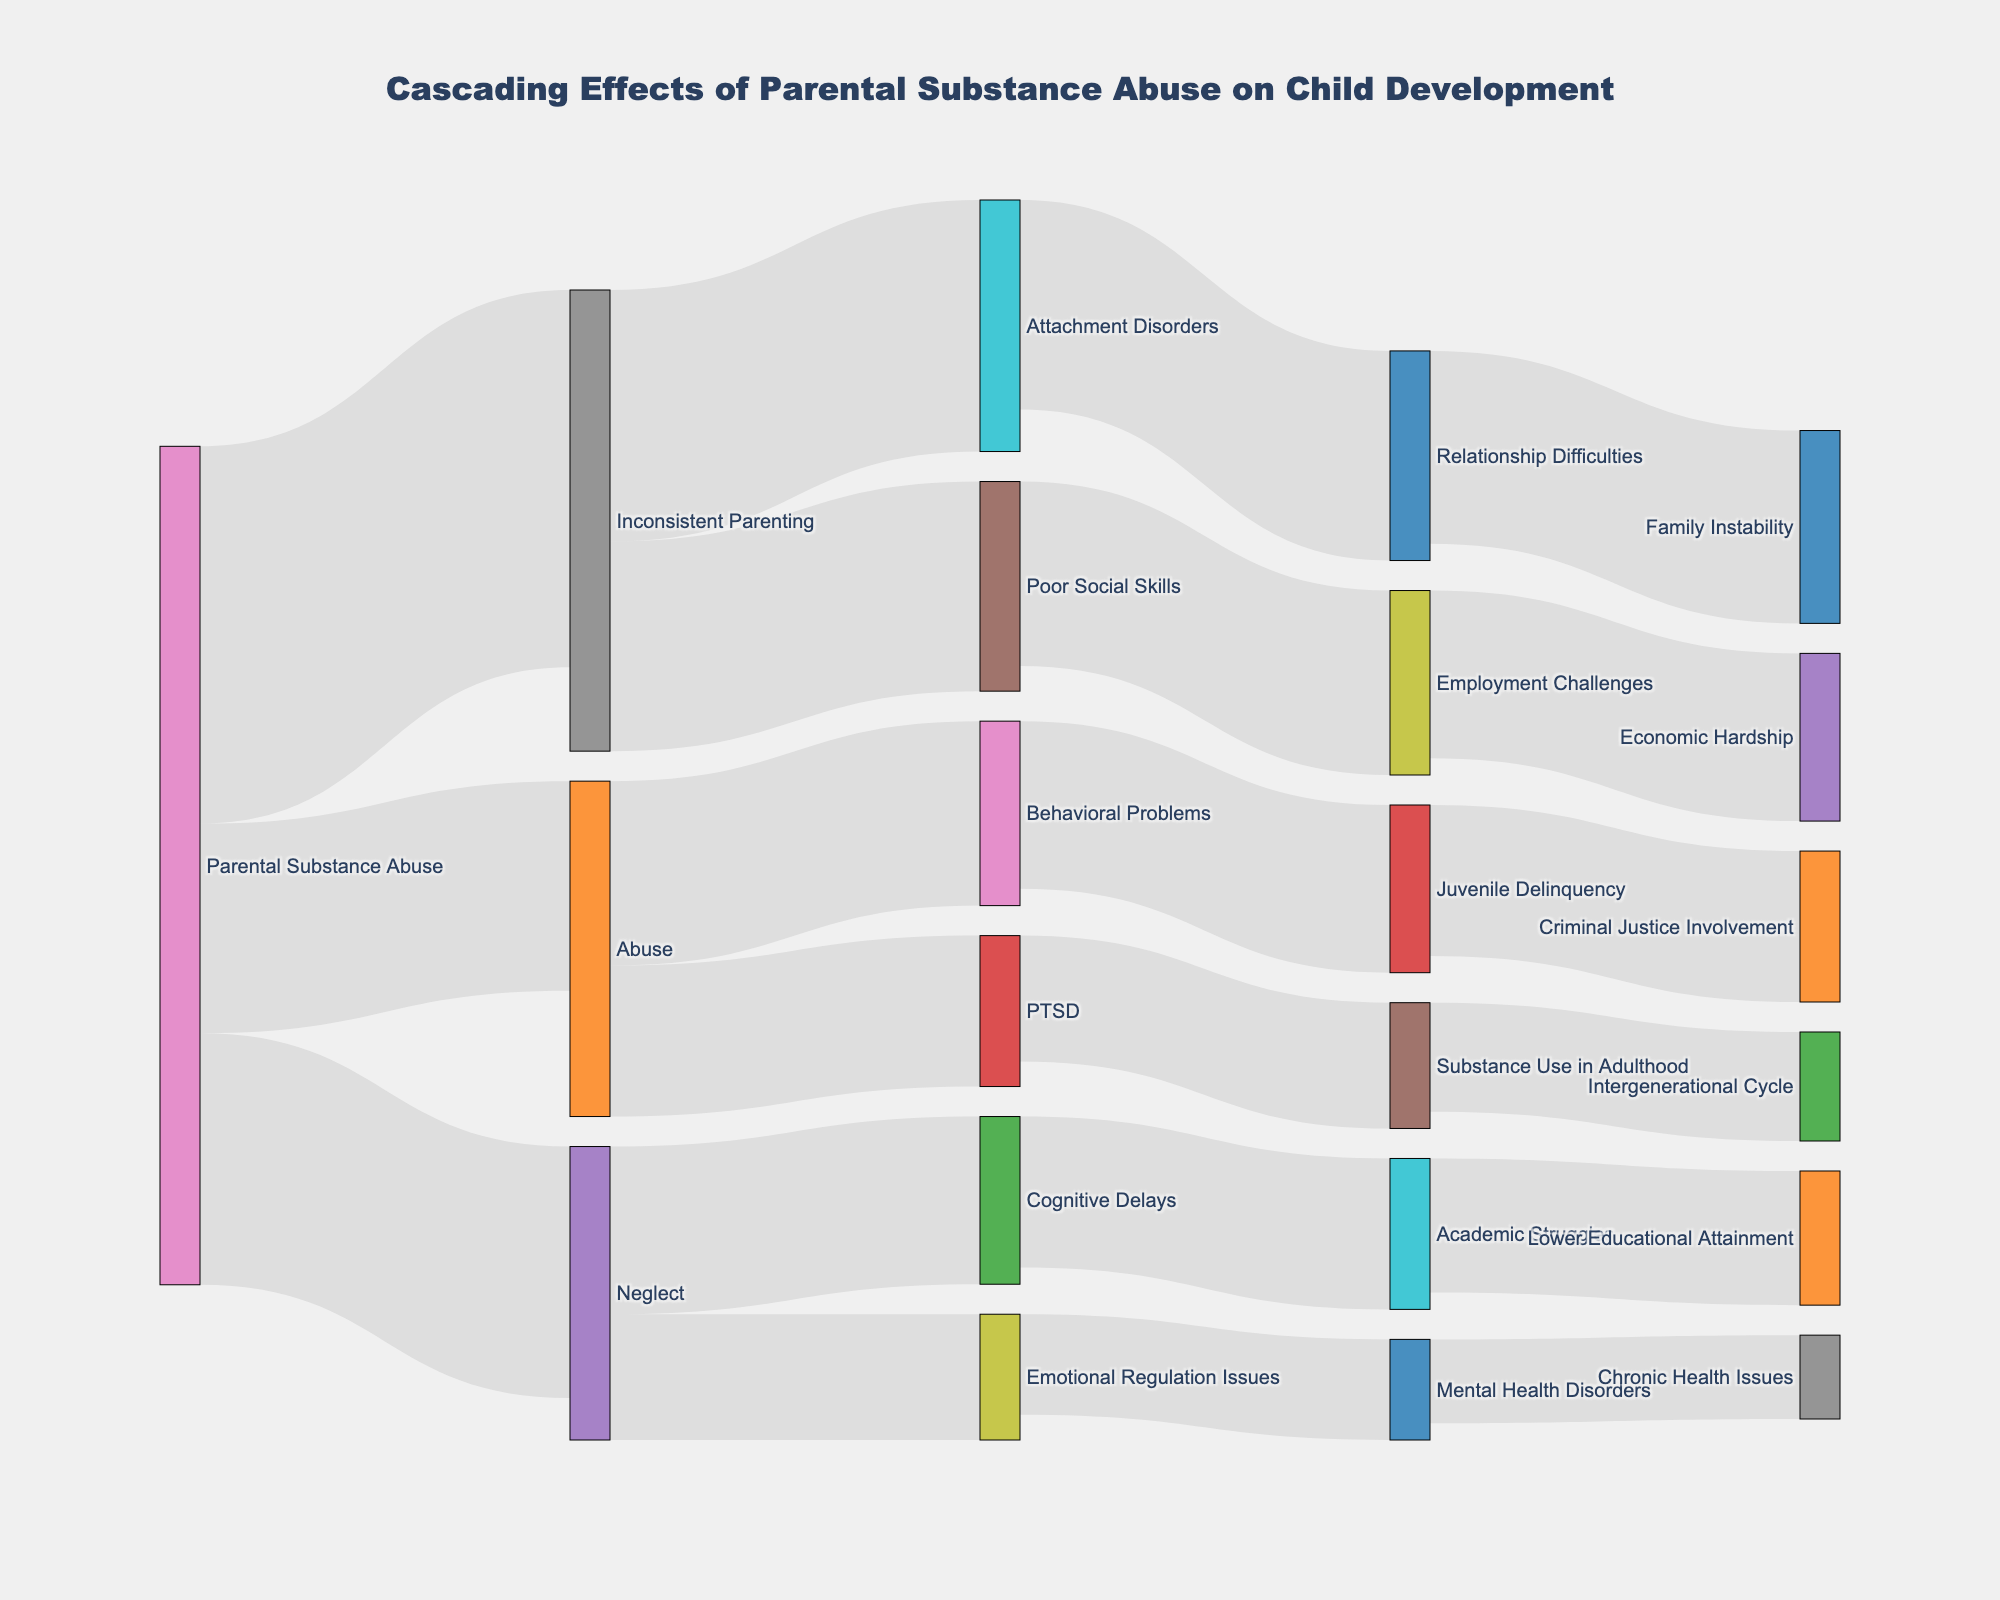What is the title of the figure? The title is usually placed at the top of the figure and gives a summary of what the visualization is about. In this case, the title is "Cascading Effects of Parental Substance Abuse on Child Development".
Answer: Cascading Effects of Parental Substance Abuse on Child Development How many parent nodes are there? The parent nodes are the initial causes or categories from which arrows originate. From the figure, the parent nodes are: "Parental Substance Abuse".
Answer: 1 Which outcome has the highest direct connection to "Parental Substance Abuse"? To answer this, look at the thickness of the arrows emanating from "Parental Substance Abuse". The thickest arrow represents the highest value. In this case, "Inconsistent Parenting" has the highest value at 45.
Answer: Inconsistent Parenting What is the total value associated with "Parental Substance Abuse"? Sum the values of all connections originating from "Parental Substance Abuse": 30 (Neglect) + 25 (Abuse) + 45 (Inconsistent Parenting) = 100.
Answer: 100 Which child development issue does "Neglect" most impact? Identify the target nodes connected to "Neglect" and compare their values. From the figure, "Cognitive Delays" has the largest connection value of 20.
Answer: Cognitive Delays Comparing "Abuse" and "Neglect," which has a higher combined impact on subsequent issues? Calculate the sum of all connections for each node:
- Neglect: 20 (Cognitive Delays) + 15 (Emotional Regulation Issues) = 35
- Abuse: 18 (PTSD) + 22 (Behavioral Problems) = 40
Therefore, Abuse has a higher combined impact.
Answer: Abuse What are the downstream effects of "PTSD"? Follow the arrows originating from "PTSD", which lead to "Substance Use in Adulthood" with a value of 15.
Answer: Substance Use in Adulthood Which outcome has the greatest number of connections leading into it? Assess the nodes to find which target node has connections from various sources. "PTSD," "Relationship Difficulties," and "Employment Challenges" each have one connection leading to them. However, "Family Instability" has one connection.
Answer: Family Instability What is the value difference between "Juvenile Delinquency" and "Academic Struggles"? The value for "Juvenile Delinquency" is 20, and for "Academic Struggles" is 18. The difference is 20 - 18 = 2.
Answer: 2 Which issue linked to "Inconsistent Parenting" has the highest value? Among the targets connected to "Inconsistent Parenting," compare the values: 30 for "Attachment Disorders" and 25 for "Poor Social Skills." "Attachment Disorders" has the highest value.
Answer: Attachment Disorders 